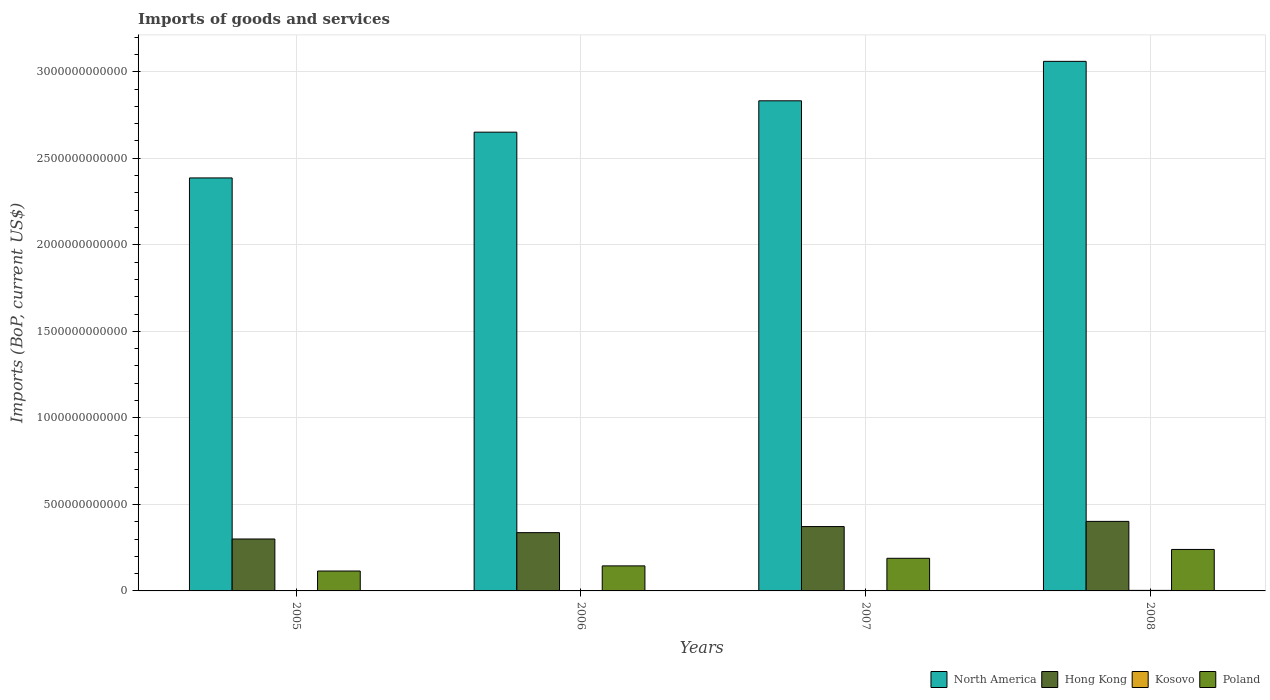How many different coloured bars are there?
Provide a succinct answer. 4. Are the number of bars on each tick of the X-axis equal?
Ensure brevity in your answer.  Yes. How many bars are there on the 2nd tick from the right?
Your response must be concise. 4. What is the label of the 4th group of bars from the left?
Your answer should be very brief. 2008. In how many cases, is the number of bars for a given year not equal to the number of legend labels?
Give a very brief answer. 0. What is the amount spent on imports in Hong Kong in 2006?
Make the answer very short. 3.37e+11. Across all years, what is the maximum amount spent on imports in Hong Kong?
Provide a short and direct response. 4.02e+11. Across all years, what is the minimum amount spent on imports in Poland?
Offer a terse response. 1.15e+11. In which year was the amount spent on imports in Kosovo minimum?
Provide a short and direct response. 2005. What is the total amount spent on imports in North America in the graph?
Offer a very short reply. 1.09e+13. What is the difference between the amount spent on imports in Poland in 2007 and that in 2008?
Offer a terse response. -5.11e+1. What is the difference between the amount spent on imports in Hong Kong in 2008 and the amount spent on imports in Kosovo in 2005?
Your answer should be very brief. 4.00e+11. What is the average amount spent on imports in Hong Kong per year?
Make the answer very short. 3.53e+11. In the year 2008, what is the difference between the amount spent on imports in Hong Kong and amount spent on imports in Poland?
Offer a terse response. 1.62e+11. What is the ratio of the amount spent on imports in Hong Kong in 2005 to that in 2007?
Make the answer very short. 0.81. Is the amount spent on imports in Poland in 2007 less than that in 2008?
Provide a short and direct response. Yes. What is the difference between the highest and the second highest amount spent on imports in Kosovo?
Provide a succinct answer. 6.61e+08. What is the difference between the highest and the lowest amount spent on imports in Kosovo?
Give a very brief answer. 1.36e+09. Is the sum of the amount spent on imports in Hong Kong in 2005 and 2006 greater than the maximum amount spent on imports in Poland across all years?
Give a very brief answer. Yes. Is it the case that in every year, the sum of the amount spent on imports in North America and amount spent on imports in Hong Kong is greater than the sum of amount spent on imports in Poland and amount spent on imports in Kosovo?
Ensure brevity in your answer.  Yes. What does the 1st bar from the left in 2006 represents?
Ensure brevity in your answer.  North America. Is it the case that in every year, the sum of the amount spent on imports in Kosovo and amount spent on imports in North America is greater than the amount spent on imports in Poland?
Your answer should be compact. Yes. How many bars are there?
Make the answer very short. 16. How many years are there in the graph?
Keep it short and to the point. 4. What is the difference between two consecutive major ticks on the Y-axis?
Your answer should be compact. 5.00e+11. Are the values on the major ticks of Y-axis written in scientific E-notation?
Keep it short and to the point. No. Where does the legend appear in the graph?
Offer a terse response. Bottom right. How many legend labels are there?
Ensure brevity in your answer.  4. How are the legend labels stacked?
Offer a very short reply. Horizontal. What is the title of the graph?
Keep it short and to the point. Imports of goods and services. What is the label or title of the Y-axis?
Make the answer very short. Imports (BoP, current US$). What is the Imports (BoP, current US$) in North America in 2005?
Offer a very short reply. 2.39e+12. What is the Imports (BoP, current US$) of Hong Kong in 2005?
Ensure brevity in your answer.  3.00e+11. What is the Imports (BoP, current US$) in Kosovo in 2005?
Provide a short and direct response. 1.76e+09. What is the Imports (BoP, current US$) in Poland in 2005?
Offer a very short reply. 1.15e+11. What is the Imports (BoP, current US$) of North America in 2006?
Offer a very short reply. 2.65e+12. What is the Imports (BoP, current US$) in Hong Kong in 2006?
Your answer should be compact. 3.37e+11. What is the Imports (BoP, current US$) in Kosovo in 2006?
Keep it short and to the point. 1.95e+09. What is the Imports (BoP, current US$) in Poland in 2006?
Keep it short and to the point. 1.45e+11. What is the Imports (BoP, current US$) in North America in 2007?
Offer a very short reply. 2.83e+12. What is the Imports (BoP, current US$) in Hong Kong in 2007?
Keep it short and to the point. 3.72e+11. What is the Imports (BoP, current US$) of Kosovo in 2007?
Offer a terse response. 2.46e+09. What is the Imports (BoP, current US$) of Poland in 2007?
Provide a short and direct response. 1.89e+11. What is the Imports (BoP, current US$) of North America in 2008?
Ensure brevity in your answer.  3.06e+12. What is the Imports (BoP, current US$) of Hong Kong in 2008?
Your response must be concise. 4.02e+11. What is the Imports (BoP, current US$) in Kosovo in 2008?
Keep it short and to the point. 3.12e+09. What is the Imports (BoP, current US$) in Poland in 2008?
Offer a terse response. 2.40e+11. Across all years, what is the maximum Imports (BoP, current US$) in North America?
Give a very brief answer. 3.06e+12. Across all years, what is the maximum Imports (BoP, current US$) in Hong Kong?
Offer a terse response. 4.02e+11. Across all years, what is the maximum Imports (BoP, current US$) in Kosovo?
Ensure brevity in your answer.  3.12e+09. Across all years, what is the maximum Imports (BoP, current US$) in Poland?
Make the answer very short. 2.40e+11. Across all years, what is the minimum Imports (BoP, current US$) in North America?
Your answer should be very brief. 2.39e+12. Across all years, what is the minimum Imports (BoP, current US$) in Hong Kong?
Your answer should be very brief. 3.00e+11. Across all years, what is the minimum Imports (BoP, current US$) of Kosovo?
Offer a very short reply. 1.76e+09. Across all years, what is the minimum Imports (BoP, current US$) in Poland?
Ensure brevity in your answer.  1.15e+11. What is the total Imports (BoP, current US$) of North America in the graph?
Offer a terse response. 1.09e+13. What is the total Imports (BoP, current US$) of Hong Kong in the graph?
Provide a short and direct response. 1.41e+12. What is the total Imports (BoP, current US$) of Kosovo in the graph?
Your answer should be very brief. 9.30e+09. What is the total Imports (BoP, current US$) of Poland in the graph?
Make the answer very short. 6.88e+11. What is the difference between the Imports (BoP, current US$) of North America in 2005 and that in 2006?
Ensure brevity in your answer.  -2.65e+11. What is the difference between the Imports (BoP, current US$) in Hong Kong in 2005 and that in 2006?
Offer a very short reply. -3.67e+1. What is the difference between the Imports (BoP, current US$) of Kosovo in 2005 and that in 2006?
Your response must be concise. -1.86e+08. What is the difference between the Imports (BoP, current US$) in Poland in 2005 and that in 2006?
Your answer should be compact. -2.97e+1. What is the difference between the Imports (BoP, current US$) in North America in 2005 and that in 2007?
Your response must be concise. -4.46e+11. What is the difference between the Imports (BoP, current US$) in Hong Kong in 2005 and that in 2007?
Offer a terse response. -7.18e+1. What is the difference between the Imports (BoP, current US$) of Kosovo in 2005 and that in 2007?
Keep it short and to the point. -6.96e+08. What is the difference between the Imports (BoP, current US$) in Poland in 2005 and that in 2007?
Offer a terse response. -7.35e+1. What is the difference between the Imports (BoP, current US$) in North America in 2005 and that in 2008?
Make the answer very short. -6.74e+11. What is the difference between the Imports (BoP, current US$) of Hong Kong in 2005 and that in 2008?
Your response must be concise. -1.02e+11. What is the difference between the Imports (BoP, current US$) in Kosovo in 2005 and that in 2008?
Provide a short and direct response. -1.36e+09. What is the difference between the Imports (BoP, current US$) in Poland in 2005 and that in 2008?
Ensure brevity in your answer.  -1.25e+11. What is the difference between the Imports (BoP, current US$) of North America in 2006 and that in 2007?
Give a very brief answer. -1.81e+11. What is the difference between the Imports (BoP, current US$) in Hong Kong in 2006 and that in 2007?
Ensure brevity in your answer.  -3.51e+1. What is the difference between the Imports (BoP, current US$) of Kosovo in 2006 and that in 2007?
Provide a succinct answer. -5.10e+08. What is the difference between the Imports (BoP, current US$) of Poland in 2006 and that in 2007?
Provide a short and direct response. -4.39e+1. What is the difference between the Imports (BoP, current US$) in North America in 2006 and that in 2008?
Keep it short and to the point. -4.09e+11. What is the difference between the Imports (BoP, current US$) of Hong Kong in 2006 and that in 2008?
Your response must be concise. -6.50e+1. What is the difference between the Imports (BoP, current US$) of Kosovo in 2006 and that in 2008?
Your response must be concise. -1.17e+09. What is the difference between the Imports (BoP, current US$) of Poland in 2006 and that in 2008?
Ensure brevity in your answer.  -9.49e+1. What is the difference between the Imports (BoP, current US$) in North America in 2007 and that in 2008?
Give a very brief answer. -2.28e+11. What is the difference between the Imports (BoP, current US$) in Hong Kong in 2007 and that in 2008?
Make the answer very short. -2.99e+1. What is the difference between the Imports (BoP, current US$) of Kosovo in 2007 and that in 2008?
Make the answer very short. -6.61e+08. What is the difference between the Imports (BoP, current US$) in Poland in 2007 and that in 2008?
Provide a short and direct response. -5.11e+1. What is the difference between the Imports (BoP, current US$) of North America in 2005 and the Imports (BoP, current US$) of Hong Kong in 2006?
Offer a terse response. 2.05e+12. What is the difference between the Imports (BoP, current US$) in North America in 2005 and the Imports (BoP, current US$) in Kosovo in 2006?
Keep it short and to the point. 2.38e+12. What is the difference between the Imports (BoP, current US$) in North America in 2005 and the Imports (BoP, current US$) in Poland in 2006?
Offer a terse response. 2.24e+12. What is the difference between the Imports (BoP, current US$) in Hong Kong in 2005 and the Imports (BoP, current US$) in Kosovo in 2006?
Provide a succinct answer. 2.98e+11. What is the difference between the Imports (BoP, current US$) of Hong Kong in 2005 and the Imports (BoP, current US$) of Poland in 2006?
Keep it short and to the point. 1.55e+11. What is the difference between the Imports (BoP, current US$) of Kosovo in 2005 and the Imports (BoP, current US$) of Poland in 2006?
Provide a succinct answer. -1.43e+11. What is the difference between the Imports (BoP, current US$) in North America in 2005 and the Imports (BoP, current US$) in Hong Kong in 2007?
Make the answer very short. 2.01e+12. What is the difference between the Imports (BoP, current US$) in North America in 2005 and the Imports (BoP, current US$) in Kosovo in 2007?
Give a very brief answer. 2.38e+12. What is the difference between the Imports (BoP, current US$) of North America in 2005 and the Imports (BoP, current US$) of Poland in 2007?
Your response must be concise. 2.20e+12. What is the difference between the Imports (BoP, current US$) in Hong Kong in 2005 and the Imports (BoP, current US$) in Kosovo in 2007?
Your answer should be very brief. 2.98e+11. What is the difference between the Imports (BoP, current US$) in Hong Kong in 2005 and the Imports (BoP, current US$) in Poland in 2007?
Your answer should be very brief. 1.12e+11. What is the difference between the Imports (BoP, current US$) of Kosovo in 2005 and the Imports (BoP, current US$) of Poland in 2007?
Give a very brief answer. -1.87e+11. What is the difference between the Imports (BoP, current US$) of North America in 2005 and the Imports (BoP, current US$) of Hong Kong in 2008?
Your answer should be compact. 1.98e+12. What is the difference between the Imports (BoP, current US$) in North America in 2005 and the Imports (BoP, current US$) in Kosovo in 2008?
Ensure brevity in your answer.  2.38e+12. What is the difference between the Imports (BoP, current US$) of North America in 2005 and the Imports (BoP, current US$) of Poland in 2008?
Provide a short and direct response. 2.15e+12. What is the difference between the Imports (BoP, current US$) in Hong Kong in 2005 and the Imports (BoP, current US$) in Kosovo in 2008?
Offer a very short reply. 2.97e+11. What is the difference between the Imports (BoP, current US$) in Hong Kong in 2005 and the Imports (BoP, current US$) in Poland in 2008?
Provide a succinct answer. 6.04e+1. What is the difference between the Imports (BoP, current US$) in Kosovo in 2005 and the Imports (BoP, current US$) in Poland in 2008?
Offer a very short reply. -2.38e+11. What is the difference between the Imports (BoP, current US$) in North America in 2006 and the Imports (BoP, current US$) in Hong Kong in 2007?
Your response must be concise. 2.28e+12. What is the difference between the Imports (BoP, current US$) in North America in 2006 and the Imports (BoP, current US$) in Kosovo in 2007?
Give a very brief answer. 2.65e+12. What is the difference between the Imports (BoP, current US$) in North America in 2006 and the Imports (BoP, current US$) in Poland in 2007?
Provide a succinct answer. 2.46e+12. What is the difference between the Imports (BoP, current US$) of Hong Kong in 2006 and the Imports (BoP, current US$) of Kosovo in 2007?
Offer a very short reply. 3.34e+11. What is the difference between the Imports (BoP, current US$) of Hong Kong in 2006 and the Imports (BoP, current US$) of Poland in 2007?
Provide a short and direct response. 1.48e+11. What is the difference between the Imports (BoP, current US$) in Kosovo in 2006 and the Imports (BoP, current US$) in Poland in 2007?
Provide a succinct answer. -1.87e+11. What is the difference between the Imports (BoP, current US$) of North America in 2006 and the Imports (BoP, current US$) of Hong Kong in 2008?
Provide a short and direct response. 2.25e+12. What is the difference between the Imports (BoP, current US$) in North America in 2006 and the Imports (BoP, current US$) in Kosovo in 2008?
Ensure brevity in your answer.  2.65e+12. What is the difference between the Imports (BoP, current US$) in North America in 2006 and the Imports (BoP, current US$) in Poland in 2008?
Your answer should be compact. 2.41e+12. What is the difference between the Imports (BoP, current US$) in Hong Kong in 2006 and the Imports (BoP, current US$) in Kosovo in 2008?
Offer a very short reply. 3.34e+11. What is the difference between the Imports (BoP, current US$) of Hong Kong in 2006 and the Imports (BoP, current US$) of Poland in 2008?
Your response must be concise. 9.71e+1. What is the difference between the Imports (BoP, current US$) in Kosovo in 2006 and the Imports (BoP, current US$) in Poland in 2008?
Offer a terse response. -2.38e+11. What is the difference between the Imports (BoP, current US$) in North America in 2007 and the Imports (BoP, current US$) in Hong Kong in 2008?
Your answer should be very brief. 2.43e+12. What is the difference between the Imports (BoP, current US$) of North America in 2007 and the Imports (BoP, current US$) of Kosovo in 2008?
Your answer should be compact. 2.83e+12. What is the difference between the Imports (BoP, current US$) in North America in 2007 and the Imports (BoP, current US$) in Poland in 2008?
Ensure brevity in your answer.  2.59e+12. What is the difference between the Imports (BoP, current US$) of Hong Kong in 2007 and the Imports (BoP, current US$) of Kosovo in 2008?
Provide a short and direct response. 3.69e+11. What is the difference between the Imports (BoP, current US$) in Hong Kong in 2007 and the Imports (BoP, current US$) in Poland in 2008?
Give a very brief answer. 1.32e+11. What is the difference between the Imports (BoP, current US$) of Kosovo in 2007 and the Imports (BoP, current US$) of Poland in 2008?
Provide a succinct answer. -2.37e+11. What is the average Imports (BoP, current US$) of North America per year?
Offer a terse response. 2.73e+12. What is the average Imports (BoP, current US$) in Hong Kong per year?
Your response must be concise. 3.53e+11. What is the average Imports (BoP, current US$) of Kosovo per year?
Offer a terse response. 2.32e+09. What is the average Imports (BoP, current US$) in Poland per year?
Your answer should be compact. 1.72e+11. In the year 2005, what is the difference between the Imports (BoP, current US$) of North America and Imports (BoP, current US$) of Hong Kong?
Ensure brevity in your answer.  2.09e+12. In the year 2005, what is the difference between the Imports (BoP, current US$) of North America and Imports (BoP, current US$) of Kosovo?
Provide a short and direct response. 2.38e+12. In the year 2005, what is the difference between the Imports (BoP, current US$) in North America and Imports (BoP, current US$) in Poland?
Provide a short and direct response. 2.27e+12. In the year 2005, what is the difference between the Imports (BoP, current US$) of Hong Kong and Imports (BoP, current US$) of Kosovo?
Keep it short and to the point. 2.98e+11. In the year 2005, what is the difference between the Imports (BoP, current US$) in Hong Kong and Imports (BoP, current US$) in Poland?
Provide a succinct answer. 1.85e+11. In the year 2005, what is the difference between the Imports (BoP, current US$) in Kosovo and Imports (BoP, current US$) in Poland?
Offer a very short reply. -1.13e+11. In the year 2006, what is the difference between the Imports (BoP, current US$) in North America and Imports (BoP, current US$) in Hong Kong?
Offer a very short reply. 2.31e+12. In the year 2006, what is the difference between the Imports (BoP, current US$) in North America and Imports (BoP, current US$) in Kosovo?
Your answer should be very brief. 2.65e+12. In the year 2006, what is the difference between the Imports (BoP, current US$) in North America and Imports (BoP, current US$) in Poland?
Provide a short and direct response. 2.51e+12. In the year 2006, what is the difference between the Imports (BoP, current US$) in Hong Kong and Imports (BoP, current US$) in Kosovo?
Your response must be concise. 3.35e+11. In the year 2006, what is the difference between the Imports (BoP, current US$) in Hong Kong and Imports (BoP, current US$) in Poland?
Give a very brief answer. 1.92e+11. In the year 2006, what is the difference between the Imports (BoP, current US$) in Kosovo and Imports (BoP, current US$) in Poland?
Ensure brevity in your answer.  -1.43e+11. In the year 2007, what is the difference between the Imports (BoP, current US$) of North America and Imports (BoP, current US$) of Hong Kong?
Offer a terse response. 2.46e+12. In the year 2007, what is the difference between the Imports (BoP, current US$) of North America and Imports (BoP, current US$) of Kosovo?
Offer a very short reply. 2.83e+12. In the year 2007, what is the difference between the Imports (BoP, current US$) of North America and Imports (BoP, current US$) of Poland?
Keep it short and to the point. 2.64e+12. In the year 2007, what is the difference between the Imports (BoP, current US$) in Hong Kong and Imports (BoP, current US$) in Kosovo?
Offer a very short reply. 3.69e+11. In the year 2007, what is the difference between the Imports (BoP, current US$) of Hong Kong and Imports (BoP, current US$) of Poland?
Make the answer very short. 1.83e+11. In the year 2007, what is the difference between the Imports (BoP, current US$) of Kosovo and Imports (BoP, current US$) of Poland?
Your answer should be very brief. -1.86e+11. In the year 2008, what is the difference between the Imports (BoP, current US$) of North America and Imports (BoP, current US$) of Hong Kong?
Your answer should be very brief. 2.66e+12. In the year 2008, what is the difference between the Imports (BoP, current US$) in North America and Imports (BoP, current US$) in Kosovo?
Your answer should be compact. 3.06e+12. In the year 2008, what is the difference between the Imports (BoP, current US$) of North America and Imports (BoP, current US$) of Poland?
Your answer should be compact. 2.82e+12. In the year 2008, what is the difference between the Imports (BoP, current US$) of Hong Kong and Imports (BoP, current US$) of Kosovo?
Your response must be concise. 3.99e+11. In the year 2008, what is the difference between the Imports (BoP, current US$) of Hong Kong and Imports (BoP, current US$) of Poland?
Make the answer very short. 1.62e+11. In the year 2008, what is the difference between the Imports (BoP, current US$) of Kosovo and Imports (BoP, current US$) of Poland?
Provide a short and direct response. -2.37e+11. What is the ratio of the Imports (BoP, current US$) of North America in 2005 to that in 2006?
Ensure brevity in your answer.  0.9. What is the ratio of the Imports (BoP, current US$) of Hong Kong in 2005 to that in 2006?
Offer a terse response. 0.89. What is the ratio of the Imports (BoP, current US$) of Kosovo in 2005 to that in 2006?
Make the answer very short. 0.9. What is the ratio of the Imports (BoP, current US$) of Poland in 2005 to that in 2006?
Your answer should be very brief. 0.79. What is the ratio of the Imports (BoP, current US$) in North America in 2005 to that in 2007?
Provide a short and direct response. 0.84. What is the ratio of the Imports (BoP, current US$) in Hong Kong in 2005 to that in 2007?
Give a very brief answer. 0.81. What is the ratio of the Imports (BoP, current US$) in Kosovo in 2005 to that in 2007?
Make the answer very short. 0.72. What is the ratio of the Imports (BoP, current US$) in Poland in 2005 to that in 2007?
Give a very brief answer. 0.61. What is the ratio of the Imports (BoP, current US$) of North America in 2005 to that in 2008?
Your answer should be compact. 0.78. What is the ratio of the Imports (BoP, current US$) of Hong Kong in 2005 to that in 2008?
Give a very brief answer. 0.75. What is the ratio of the Imports (BoP, current US$) in Kosovo in 2005 to that in 2008?
Give a very brief answer. 0.57. What is the ratio of the Imports (BoP, current US$) in Poland in 2005 to that in 2008?
Make the answer very short. 0.48. What is the ratio of the Imports (BoP, current US$) in North America in 2006 to that in 2007?
Your response must be concise. 0.94. What is the ratio of the Imports (BoP, current US$) of Hong Kong in 2006 to that in 2007?
Make the answer very short. 0.91. What is the ratio of the Imports (BoP, current US$) in Kosovo in 2006 to that in 2007?
Offer a terse response. 0.79. What is the ratio of the Imports (BoP, current US$) in Poland in 2006 to that in 2007?
Offer a terse response. 0.77. What is the ratio of the Imports (BoP, current US$) of North America in 2006 to that in 2008?
Offer a terse response. 0.87. What is the ratio of the Imports (BoP, current US$) in Hong Kong in 2006 to that in 2008?
Offer a very short reply. 0.84. What is the ratio of the Imports (BoP, current US$) in Kosovo in 2006 to that in 2008?
Your answer should be compact. 0.62. What is the ratio of the Imports (BoP, current US$) in Poland in 2006 to that in 2008?
Make the answer very short. 0.6. What is the ratio of the Imports (BoP, current US$) of North America in 2007 to that in 2008?
Provide a short and direct response. 0.93. What is the ratio of the Imports (BoP, current US$) in Hong Kong in 2007 to that in 2008?
Your response must be concise. 0.93. What is the ratio of the Imports (BoP, current US$) of Kosovo in 2007 to that in 2008?
Offer a very short reply. 0.79. What is the ratio of the Imports (BoP, current US$) of Poland in 2007 to that in 2008?
Provide a succinct answer. 0.79. What is the difference between the highest and the second highest Imports (BoP, current US$) in North America?
Keep it short and to the point. 2.28e+11. What is the difference between the highest and the second highest Imports (BoP, current US$) in Hong Kong?
Your answer should be very brief. 2.99e+1. What is the difference between the highest and the second highest Imports (BoP, current US$) in Kosovo?
Ensure brevity in your answer.  6.61e+08. What is the difference between the highest and the second highest Imports (BoP, current US$) of Poland?
Make the answer very short. 5.11e+1. What is the difference between the highest and the lowest Imports (BoP, current US$) in North America?
Your response must be concise. 6.74e+11. What is the difference between the highest and the lowest Imports (BoP, current US$) of Hong Kong?
Ensure brevity in your answer.  1.02e+11. What is the difference between the highest and the lowest Imports (BoP, current US$) of Kosovo?
Provide a short and direct response. 1.36e+09. What is the difference between the highest and the lowest Imports (BoP, current US$) in Poland?
Keep it short and to the point. 1.25e+11. 